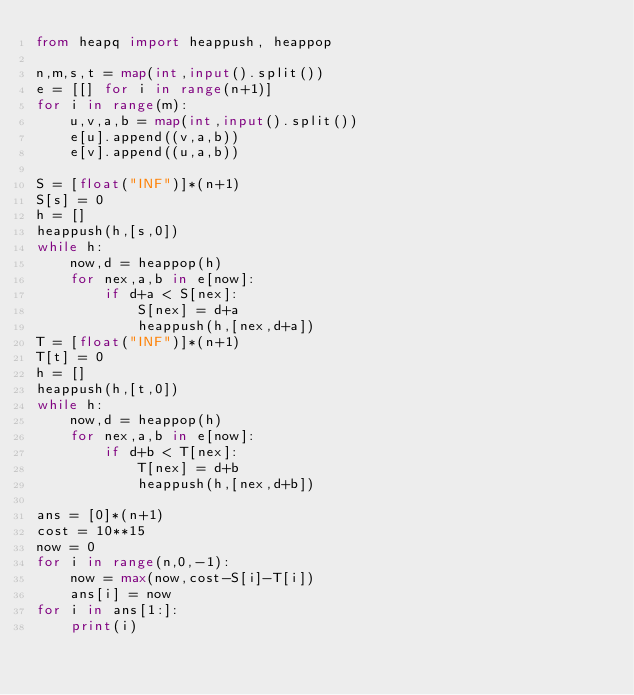Convert code to text. <code><loc_0><loc_0><loc_500><loc_500><_Python_>from heapq import heappush, heappop

n,m,s,t = map(int,input().split())
e = [[] for i in range(n+1)]
for i in range(m):
    u,v,a,b = map(int,input().split())
    e[u].append((v,a,b))
    e[v].append((u,a,b))

S = [float("INF")]*(n+1)
S[s] = 0
h = []
heappush(h,[s,0])
while h:
    now,d = heappop(h)
    for nex,a,b in e[now]:
        if d+a < S[nex]:
            S[nex] = d+a
            heappush(h,[nex,d+a])
T = [float("INF")]*(n+1)
T[t] = 0
h = []
heappush(h,[t,0])
while h:
    now,d = heappop(h)
    for nex,a,b in e[now]:
        if d+b < T[nex]:
            T[nex] = d+b
            heappush(h,[nex,d+b])

ans = [0]*(n+1)
cost = 10**15
now = 0
for i in range(n,0,-1):
    now = max(now,cost-S[i]-T[i])
    ans[i] = now
for i in ans[1:]:
    print(i)</code> 